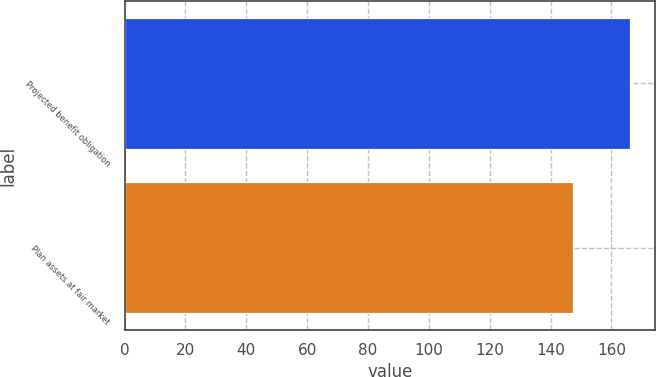Convert chart to OTSL. <chart><loc_0><loc_0><loc_500><loc_500><bar_chart><fcel>Projected benefit obligation<fcel>Plan assets at fair market<nl><fcel>166<fcel>147.2<nl></chart> 